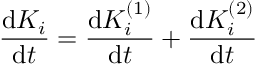Convert formula to latex. <formula><loc_0><loc_0><loc_500><loc_500>\frac { d K _ { i } } { d t } = \frac { d K _ { i } ^ { ( 1 ) } } { d t } + \frac { d K _ { i } ^ { ( 2 ) } } { d t }</formula> 